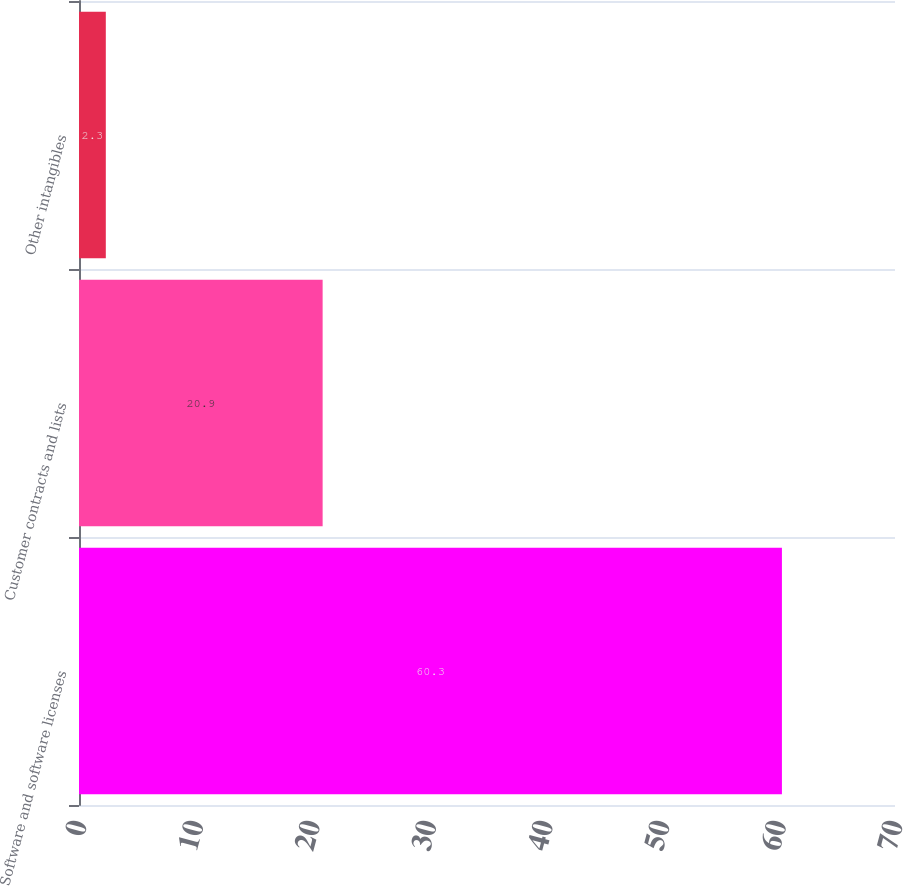Convert chart to OTSL. <chart><loc_0><loc_0><loc_500><loc_500><bar_chart><fcel>Software and software licenses<fcel>Customer contracts and lists<fcel>Other intangibles<nl><fcel>60.3<fcel>20.9<fcel>2.3<nl></chart> 